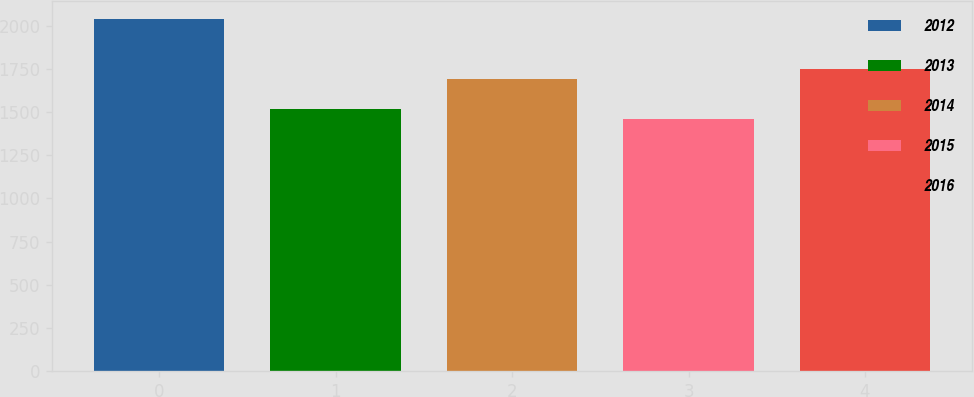Convert chart. <chart><loc_0><loc_0><loc_500><loc_500><bar_chart><fcel>2012<fcel>2013<fcel>2014<fcel>2015<fcel>2016<nl><fcel>2041<fcel>1519.9<fcel>1690<fcel>1462<fcel>1747.9<nl></chart> 